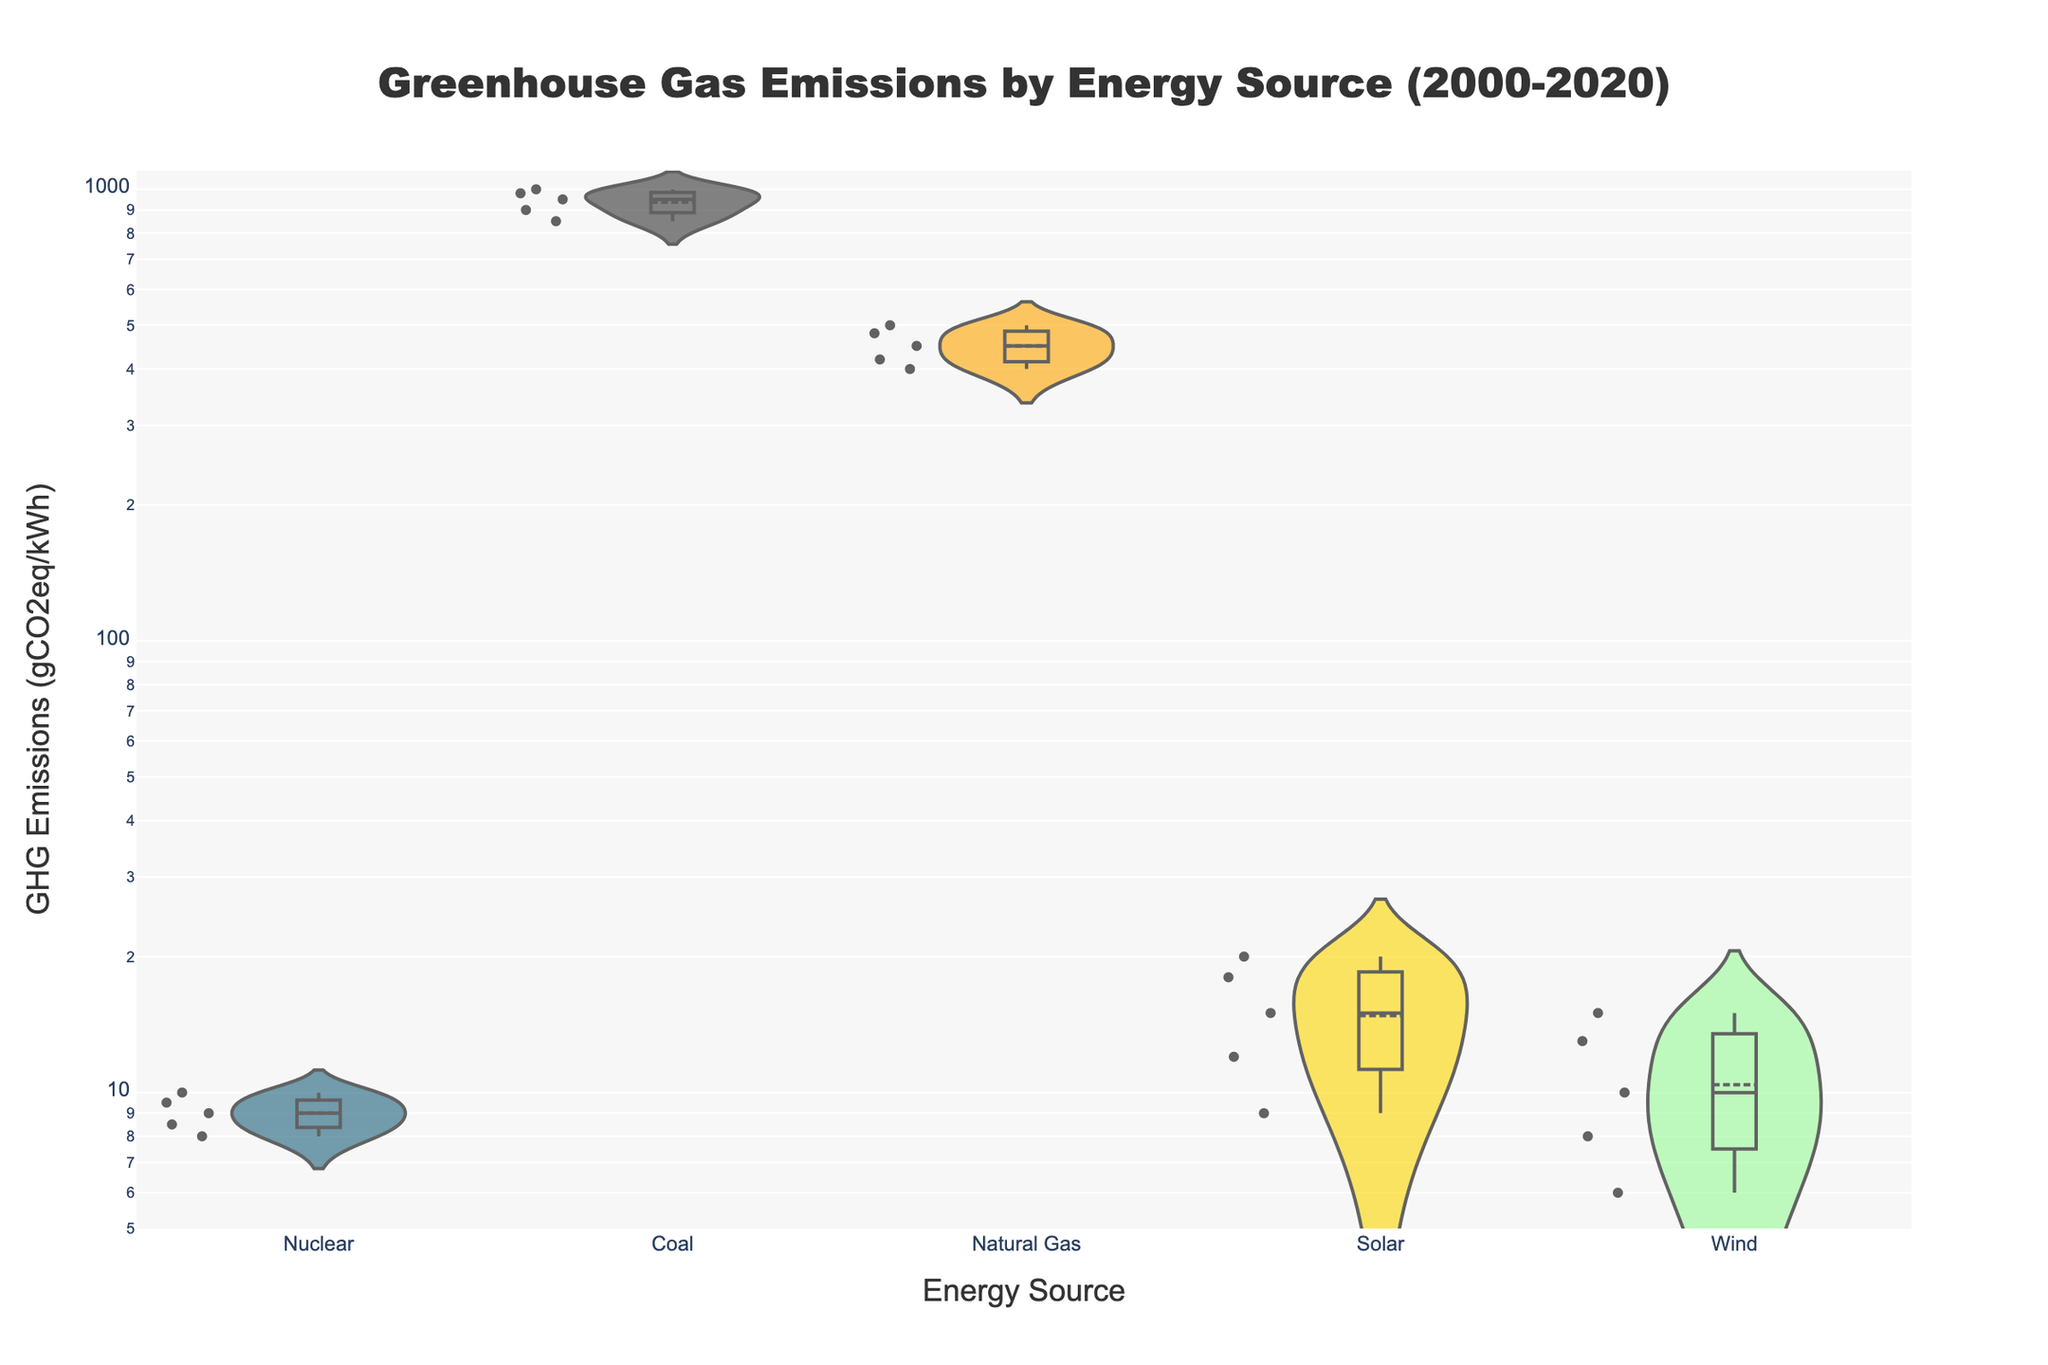What is the title of the figure? The title of the figure is present at the top of the chart, centrally aligned.
Answer: Greenhouse Gas Emissions by Energy Source (2000-2020) Which energy source shows the highest GHG emissions according to the plot? According to the plot, the energy source with the highest GHG emissions can be seen through the vertical position of its data points.
Answer: Coal How do the greenhouse gas emissions from nuclear energy compare to those from wind energy? To compare the emissions, look at the position of the data points for each. Nuclear emissions range from 8 to 10 gCO2eq/kWh while wind ranges from 6 to 15 gCO2eq/kWh.
Answer: Nuclear energy emissions are slightly higher than wind but both are low overall Which energy source has the lowest greenhouse gas emissions in 2020? Looking at the last data points for each energy source, the lowest emissions for 2020 are evident. Wind energy has emissions of 6 gCO2eq/kWh in 2020, which is the lowest value.
Answer: Wind What trend can you observe for coal's greenhouse gas emissions from 2000 to 2020? By analyzing the data points for coal over time, you notice a decrease from 1000 gCO2eq/kWh in 2000 to 850 gCO2eq/kWh in 2020.
Answer: Coal emissions have decreased over time What color represents solar energy in the plot? The plot uses a distinct color for each energy source. Solar energy is represented by a sunny, gold-yellow color.
Answer: Gold-yellow Which energy source has shown a consistent decline in greenhouse gas emissions over the years? Observe the lines connecting the data points for each energy source. Nuclear energy shows a consistent decline from 10 to 8 gCO2eq/kWh over the years.
Answer: Nuclear How do the ranges of greenhouse gas emissions for natural gas and solar energy compare? Compare the vertical range values for both energy sources. Natural gas ranges from 500 to 400 gCO2eq/kWh, while solar ranges from 20 to 9 gCO2eq/kWh.
Answer: Natural gas has a higher range of emissions compared to solar energy What does the box and meanline visible in each data source's violin plot represent? The box in the violin plot represents the interquartile range (IQR) and the meanline shows the average value.
Answer: The box is the IQR, and the line is the average value Why might someone advocate for increased use of nuclear energy based on this plot? Nuclear energy shows low and significantly declining emissions compared to other sources, which is favorable for reducing greenhouse gas emissions.
Answer: Low and declining emissions 